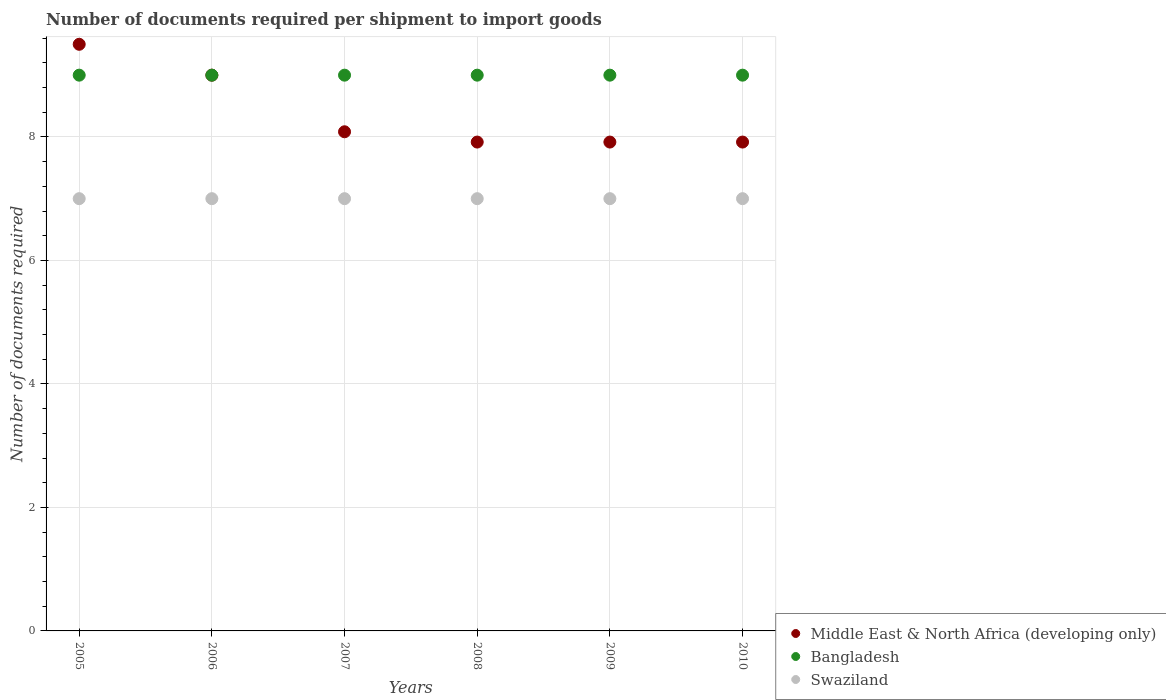How many different coloured dotlines are there?
Provide a succinct answer. 3. What is the number of documents required per shipment to import goods in Middle East & North Africa (developing only) in 2007?
Make the answer very short. 8.08. Across all years, what is the maximum number of documents required per shipment to import goods in Bangladesh?
Your answer should be compact. 9. Across all years, what is the minimum number of documents required per shipment to import goods in Middle East & North Africa (developing only)?
Your answer should be very brief. 7.92. In which year was the number of documents required per shipment to import goods in Middle East & North Africa (developing only) maximum?
Your response must be concise. 2005. In which year was the number of documents required per shipment to import goods in Bangladesh minimum?
Provide a succinct answer. 2005. What is the total number of documents required per shipment to import goods in Swaziland in the graph?
Ensure brevity in your answer.  42. What is the difference between the number of documents required per shipment to import goods in Bangladesh in 2007 and that in 2008?
Provide a succinct answer. 0. What is the difference between the number of documents required per shipment to import goods in Bangladesh in 2005 and the number of documents required per shipment to import goods in Swaziland in 2010?
Ensure brevity in your answer.  2. What is the average number of documents required per shipment to import goods in Bangladesh per year?
Provide a succinct answer. 9. In the year 2006, what is the difference between the number of documents required per shipment to import goods in Bangladesh and number of documents required per shipment to import goods in Swaziland?
Offer a very short reply. 2. What is the ratio of the number of documents required per shipment to import goods in Middle East & North Africa (developing only) in 2006 to that in 2009?
Provide a short and direct response. 1.14. Is the difference between the number of documents required per shipment to import goods in Bangladesh in 2006 and 2009 greater than the difference between the number of documents required per shipment to import goods in Swaziland in 2006 and 2009?
Offer a very short reply. No. What is the difference between the highest and the lowest number of documents required per shipment to import goods in Swaziland?
Provide a short and direct response. 0. In how many years, is the number of documents required per shipment to import goods in Bangladesh greater than the average number of documents required per shipment to import goods in Bangladesh taken over all years?
Offer a very short reply. 0. Is the sum of the number of documents required per shipment to import goods in Middle East & North Africa (developing only) in 2005 and 2007 greater than the maximum number of documents required per shipment to import goods in Bangladesh across all years?
Offer a very short reply. Yes. Is it the case that in every year, the sum of the number of documents required per shipment to import goods in Swaziland and number of documents required per shipment to import goods in Bangladesh  is greater than the number of documents required per shipment to import goods in Middle East & North Africa (developing only)?
Make the answer very short. Yes. Is the number of documents required per shipment to import goods in Swaziland strictly greater than the number of documents required per shipment to import goods in Middle East & North Africa (developing only) over the years?
Your answer should be very brief. No. How many dotlines are there?
Keep it short and to the point. 3. How many years are there in the graph?
Ensure brevity in your answer.  6. What is the difference between two consecutive major ticks on the Y-axis?
Your response must be concise. 2. Are the values on the major ticks of Y-axis written in scientific E-notation?
Your answer should be compact. No. Does the graph contain any zero values?
Keep it short and to the point. No. Does the graph contain grids?
Offer a very short reply. Yes. How many legend labels are there?
Your answer should be very brief. 3. What is the title of the graph?
Provide a succinct answer. Number of documents required per shipment to import goods. What is the label or title of the X-axis?
Your answer should be very brief. Years. What is the label or title of the Y-axis?
Offer a terse response. Number of documents required. What is the Number of documents required in Swaziland in 2005?
Keep it short and to the point. 7. What is the Number of documents required in Middle East & North Africa (developing only) in 2006?
Provide a succinct answer. 9. What is the Number of documents required in Bangladesh in 2006?
Offer a terse response. 9. What is the Number of documents required in Middle East & North Africa (developing only) in 2007?
Provide a short and direct response. 8.08. What is the Number of documents required of Bangladesh in 2007?
Provide a succinct answer. 9. What is the Number of documents required in Swaziland in 2007?
Offer a very short reply. 7. What is the Number of documents required in Middle East & North Africa (developing only) in 2008?
Offer a terse response. 7.92. What is the Number of documents required of Bangladesh in 2008?
Keep it short and to the point. 9. What is the Number of documents required of Swaziland in 2008?
Provide a short and direct response. 7. What is the Number of documents required in Middle East & North Africa (developing only) in 2009?
Keep it short and to the point. 7.92. What is the Number of documents required of Bangladesh in 2009?
Give a very brief answer. 9. What is the Number of documents required in Swaziland in 2009?
Keep it short and to the point. 7. What is the Number of documents required of Middle East & North Africa (developing only) in 2010?
Provide a succinct answer. 7.92. What is the Number of documents required in Bangladesh in 2010?
Give a very brief answer. 9. Across all years, what is the maximum Number of documents required of Bangladesh?
Give a very brief answer. 9. Across all years, what is the maximum Number of documents required in Swaziland?
Your response must be concise. 7. Across all years, what is the minimum Number of documents required of Middle East & North Africa (developing only)?
Give a very brief answer. 7.92. Across all years, what is the minimum Number of documents required in Bangladesh?
Keep it short and to the point. 9. What is the total Number of documents required in Middle East & North Africa (developing only) in the graph?
Provide a succinct answer. 50.33. What is the total Number of documents required of Bangladesh in the graph?
Make the answer very short. 54. What is the total Number of documents required of Swaziland in the graph?
Make the answer very short. 42. What is the difference between the Number of documents required of Middle East & North Africa (developing only) in 2005 and that in 2007?
Your answer should be very brief. 1.42. What is the difference between the Number of documents required of Bangladesh in 2005 and that in 2007?
Make the answer very short. 0. What is the difference between the Number of documents required in Swaziland in 2005 and that in 2007?
Ensure brevity in your answer.  0. What is the difference between the Number of documents required in Middle East & North Africa (developing only) in 2005 and that in 2008?
Keep it short and to the point. 1.58. What is the difference between the Number of documents required of Bangladesh in 2005 and that in 2008?
Your response must be concise. 0. What is the difference between the Number of documents required of Swaziland in 2005 and that in 2008?
Offer a terse response. 0. What is the difference between the Number of documents required of Middle East & North Africa (developing only) in 2005 and that in 2009?
Ensure brevity in your answer.  1.58. What is the difference between the Number of documents required of Middle East & North Africa (developing only) in 2005 and that in 2010?
Offer a terse response. 1.58. What is the difference between the Number of documents required in Swaziland in 2005 and that in 2010?
Keep it short and to the point. 0. What is the difference between the Number of documents required in Middle East & North Africa (developing only) in 2006 and that in 2007?
Ensure brevity in your answer.  0.92. What is the difference between the Number of documents required in Swaziland in 2006 and that in 2007?
Ensure brevity in your answer.  0. What is the difference between the Number of documents required in Middle East & North Africa (developing only) in 2006 and that in 2008?
Make the answer very short. 1.08. What is the difference between the Number of documents required in Swaziland in 2006 and that in 2008?
Provide a short and direct response. 0. What is the difference between the Number of documents required in Middle East & North Africa (developing only) in 2006 and that in 2009?
Offer a terse response. 1.08. What is the difference between the Number of documents required of Swaziland in 2006 and that in 2009?
Ensure brevity in your answer.  0. What is the difference between the Number of documents required of Middle East & North Africa (developing only) in 2006 and that in 2010?
Your response must be concise. 1.08. What is the difference between the Number of documents required of Swaziland in 2006 and that in 2010?
Provide a short and direct response. 0. What is the difference between the Number of documents required of Swaziland in 2007 and that in 2008?
Provide a succinct answer. 0. What is the difference between the Number of documents required in Middle East & North Africa (developing only) in 2007 and that in 2009?
Provide a short and direct response. 0.17. What is the difference between the Number of documents required of Bangladesh in 2007 and that in 2009?
Provide a succinct answer. 0. What is the difference between the Number of documents required in Swaziland in 2007 and that in 2009?
Your answer should be very brief. 0. What is the difference between the Number of documents required in Bangladesh in 2007 and that in 2010?
Provide a succinct answer. 0. What is the difference between the Number of documents required of Swaziland in 2007 and that in 2010?
Give a very brief answer. 0. What is the difference between the Number of documents required of Middle East & North Africa (developing only) in 2008 and that in 2010?
Offer a very short reply. 0. What is the difference between the Number of documents required of Bangladesh in 2009 and that in 2010?
Your answer should be compact. 0. What is the difference between the Number of documents required of Swaziland in 2009 and that in 2010?
Your answer should be very brief. 0. What is the difference between the Number of documents required of Middle East & North Africa (developing only) in 2005 and the Number of documents required of Swaziland in 2006?
Your response must be concise. 2.5. What is the difference between the Number of documents required in Bangladesh in 2005 and the Number of documents required in Swaziland in 2006?
Make the answer very short. 2. What is the difference between the Number of documents required of Middle East & North Africa (developing only) in 2005 and the Number of documents required of Bangladesh in 2007?
Give a very brief answer. 0.5. What is the difference between the Number of documents required in Bangladesh in 2005 and the Number of documents required in Swaziland in 2007?
Your answer should be compact. 2. What is the difference between the Number of documents required of Middle East & North Africa (developing only) in 2005 and the Number of documents required of Bangladesh in 2008?
Your answer should be very brief. 0.5. What is the difference between the Number of documents required of Middle East & North Africa (developing only) in 2005 and the Number of documents required of Swaziland in 2008?
Ensure brevity in your answer.  2.5. What is the difference between the Number of documents required of Bangladesh in 2005 and the Number of documents required of Swaziland in 2008?
Provide a short and direct response. 2. What is the difference between the Number of documents required in Middle East & North Africa (developing only) in 2005 and the Number of documents required in Bangladesh in 2009?
Your answer should be very brief. 0.5. What is the difference between the Number of documents required of Middle East & North Africa (developing only) in 2005 and the Number of documents required of Swaziland in 2009?
Your answer should be very brief. 2.5. What is the difference between the Number of documents required of Middle East & North Africa (developing only) in 2005 and the Number of documents required of Bangladesh in 2010?
Your answer should be very brief. 0.5. What is the difference between the Number of documents required of Bangladesh in 2005 and the Number of documents required of Swaziland in 2010?
Keep it short and to the point. 2. What is the difference between the Number of documents required in Middle East & North Africa (developing only) in 2006 and the Number of documents required in Swaziland in 2007?
Ensure brevity in your answer.  2. What is the difference between the Number of documents required of Bangladesh in 2006 and the Number of documents required of Swaziland in 2007?
Offer a very short reply. 2. What is the difference between the Number of documents required in Middle East & North Africa (developing only) in 2006 and the Number of documents required in Swaziland in 2008?
Your answer should be compact. 2. What is the difference between the Number of documents required in Bangladesh in 2006 and the Number of documents required in Swaziland in 2008?
Provide a short and direct response. 2. What is the difference between the Number of documents required in Middle East & North Africa (developing only) in 2006 and the Number of documents required in Bangladesh in 2009?
Give a very brief answer. 0. What is the difference between the Number of documents required in Middle East & North Africa (developing only) in 2006 and the Number of documents required in Swaziland in 2009?
Ensure brevity in your answer.  2. What is the difference between the Number of documents required of Middle East & North Africa (developing only) in 2006 and the Number of documents required of Swaziland in 2010?
Your answer should be very brief. 2. What is the difference between the Number of documents required of Middle East & North Africa (developing only) in 2007 and the Number of documents required of Bangladesh in 2008?
Keep it short and to the point. -0.92. What is the difference between the Number of documents required in Middle East & North Africa (developing only) in 2007 and the Number of documents required in Swaziland in 2008?
Make the answer very short. 1.08. What is the difference between the Number of documents required in Bangladesh in 2007 and the Number of documents required in Swaziland in 2008?
Offer a terse response. 2. What is the difference between the Number of documents required of Middle East & North Africa (developing only) in 2007 and the Number of documents required of Bangladesh in 2009?
Your response must be concise. -0.92. What is the difference between the Number of documents required in Middle East & North Africa (developing only) in 2007 and the Number of documents required in Bangladesh in 2010?
Make the answer very short. -0.92. What is the difference between the Number of documents required in Middle East & North Africa (developing only) in 2007 and the Number of documents required in Swaziland in 2010?
Provide a short and direct response. 1.08. What is the difference between the Number of documents required of Middle East & North Africa (developing only) in 2008 and the Number of documents required of Bangladesh in 2009?
Your response must be concise. -1.08. What is the difference between the Number of documents required of Bangladesh in 2008 and the Number of documents required of Swaziland in 2009?
Provide a succinct answer. 2. What is the difference between the Number of documents required of Middle East & North Africa (developing only) in 2008 and the Number of documents required of Bangladesh in 2010?
Your response must be concise. -1.08. What is the difference between the Number of documents required in Bangladesh in 2008 and the Number of documents required in Swaziland in 2010?
Provide a short and direct response. 2. What is the difference between the Number of documents required in Middle East & North Africa (developing only) in 2009 and the Number of documents required in Bangladesh in 2010?
Give a very brief answer. -1.08. What is the average Number of documents required of Middle East & North Africa (developing only) per year?
Give a very brief answer. 8.39. What is the average Number of documents required of Swaziland per year?
Your response must be concise. 7. In the year 2005, what is the difference between the Number of documents required in Middle East & North Africa (developing only) and Number of documents required in Bangladesh?
Your answer should be very brief. 0.5. In the year 2005, what is the difference between the Number of documents required of Bangladesh and Number of documents required of Swaziland?
Keep it short and to the point. 2. In the year 2006, what is the difference between the Number of documents required of Middle East & North Africa (developing only) and Number of documents required of Bangladesh?
Provide a short and direct response. 0. In the year 2007, what is the difference between the Number of documents required in Middle East & North Africa (developing only) and Number of documents required in Bangladesh?
Keep it short and to the point. -0.92. In the year 2007, what is the difference between the Number of documents required of Middle East & North Africa (developing only) and Number of documents required of Swaziland?
Ensure brevity in your answer.  1.08. In the year 2008, what is the difference between the Number of documents required of Middle East & North Africa (developing only) and Number of documents required of Bangladesh?
Give a very brief answer. -1.08. In the year 2008, what is the difference between the Number of documents required of Middle East & North Africa (developing only) and Number of documents required of Swaziland?
Provide a succinct answer. 0.92. In the year 2009, what is the difference between the Number of documents required of Middle East & North Africa (developing only) and Number of documents required of Bangladesh?
Your response must be concise. -1.08. In the year 2009, what is the difference between the Number of documents required in Middle East & North Africa (developing only) and Number of documents required in Swaziland?
Offer a terse response. 0.92. In the year 2010, what is the difference between the Number of documents required in Middle East & North Africa (developing only) and Number of documents required in Bangladesh?
Give a very brief answer. -1.08. What is the ratio of the Number of documents required in Middle East & North Africa (developing only) in 2005 to that in 2006?
Make the answer very short. 1.06. What is the ratio of the Number of documents required in Middle East & North Africa (developing only) in 2005 to that in 2007?
Offer a very short reply. 1.18. What is the ratio of the Number of documents required of Swaziland in 2005 to that in 2007?
Provide a succinct answer. 1. What is the ratio of the Number of documents required of Bangladesh in 2005 to that in 2008?
Provide a short and direct response. 1. What is the ratio of the Number of documents required in Swaziland in 2005 to that in 2008?
Give a very brief answer. 1. What is the ratio of the Number of documents required of Bangladesh in 2005 to that in 2009?
Your answer should be compact. 1. What is the ratio of the Number of documents required of Swaziland in 2005 to that in 2009?
Provide a succinct answer. 1. What is the ratio of the Number of documents required of Swaziland in 2005 to that in 2010?
Your response must be concise. 1. What is the ratio of the Number of documents required of Middle East & North Africa (developing only) in 2006 to that in 2007?
Offer a very short reply. 1.11. What is the ratio of the Number of documents required of Bangladesh in 2006 to that in 2007?
Offer a terse response. 1. What is the ratio of the Number of documents required in Swaziland in 2006 to that in 2007?
Your answer should be compact. 1. What is the ratio of the Number of documents required in Middle East & North Africa (developing only) in 2006 to that in 2008?
Ensure brevity in your answer.  1.14. What is the ratio of the Number of documents required of Swaziland in 2006 to that in 2008?
Your answer should be compact. 1. What is the ratio of the Number of documents required in Middle East & North Africa (developing only) in 2006 to that in 2009?
Your answer should be very brief. 1.14. What is the ratio of the Number of documents required of Swaziland in 2006 to that in 2009?
Your response must be concise. 1. What is the ratio of the Number of documents required of Middle East & North Africa (developing only) in 2006 to that in 2010?
Keep it short and to the point. 1.14. What is the ratio of the Number of documents required in Middle East & North Africa (developing only) in 2007 to that in 2008?
Provide a short and direct response. 1.02. What is the ratio of the Number of documents required in Swaziland in 2007 to that in 2008?
Give a very brief answer. 1. What is the ratio of the Number of documents required in Middle East & North Africa (developing only) in 2007 to that in 2009?
Make the answer very short. 1.02. What is the ratio of the Number of documents required in Middle East & North Africa (developing only) in 2007 to that in 2010?
Keep it short and to the point. 1.02. What is the ratio of the Number of documents required of Bangladesh in 2007 to that in 2010?
Make the answer very short. 1. What is the ratio of the Number of documents required in Swaziland in 2007 to that in 2010?
Your answer should be compact. 1. What is the ratio of the Number of documents required in Bangladesh in 2008 to that in 2009?
Provide a short and direct response. 1. What is the ratio of the Number of documents required of Bangladesh in 2008 to that in 2010?
Offer a very short reply. 1. What is the difference between the highest and the second highest Number of documents required of Middle East & North Africa (developing only)?
Make the answer very short. 0.5. What is the difference between the highest and the second highest Number of documents required in Bangladesh?
Ensure brevity in your answer.  0. What is the difference between the highest and the lowest Number of documents required of Middle East & North Africa (developing only)?
Your answer should be compact. 1.58. What is the difference between the highest and the lowest Number of documents required of Bangladesh?
Offer a terse response. 0. What is the difference between the highest and the lowest Number of documents required of Swaziland?
Your answer should be very brief. 0. 